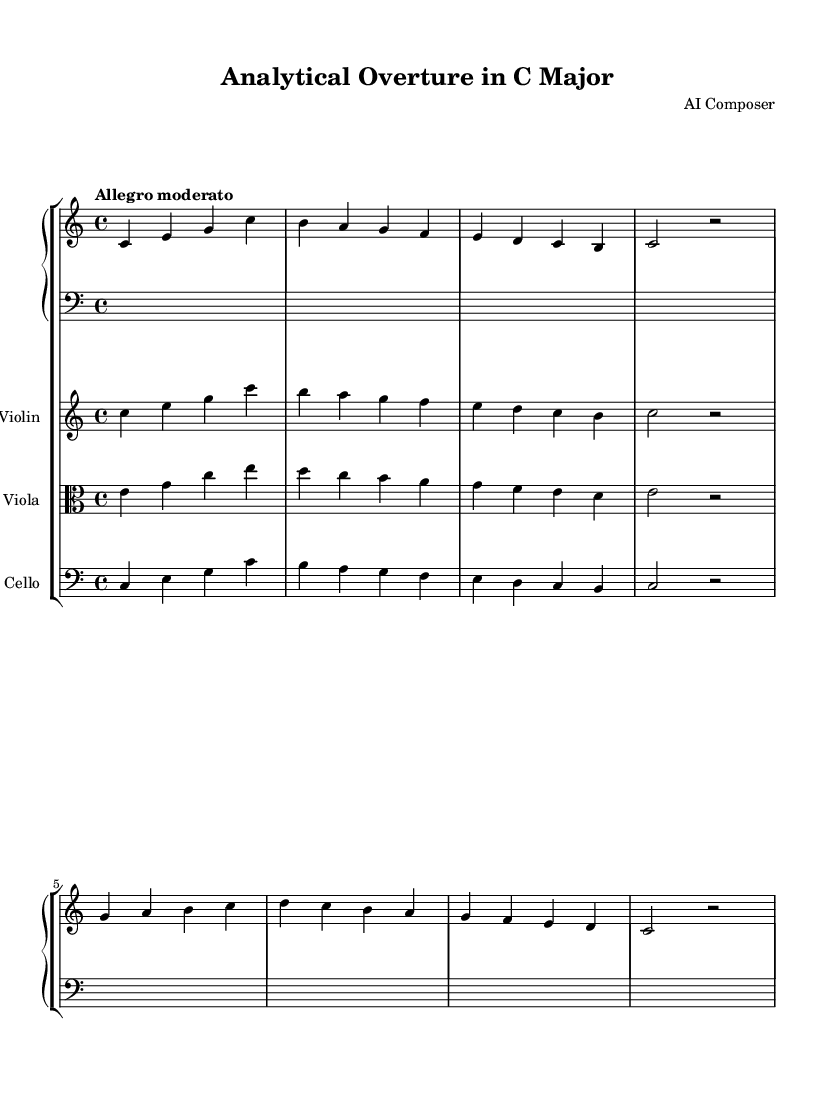What is the key signature of this music? The key signature is C major, which has no sharps or flats, as indicated by the absence of any accidentals at the beginning of the staff.
Answer: C major What is the time signature of this music? The time signature is 4/4, denoted by the notation found at the beginning of the score, meaning there are four beats per measure, and the quarter note gets one beat.
Answer: 4/4 What is the tempo marking of this piece? The tempo marking is "Allegro moderato," which suggests a moderately fast pace and can be found at the beginning above the staff.
Answer: Allegro moderato Which instrument plays the lowest notes? The cello plays the lowest notes, as it is written in the bass clef and its pitches are lower than those of the violin and viola.
Answer: Cello How many measures are in the piano part? The piano part has a total of eight measures, counted by the distinct groups of notes separated by vertical lines in the notation.
Answer: Eight What is the melodic range of the violin part? The violin part has a melodic range that spans from C to C', which starts from the lower C note and goes up to the higher C note an octave above.
Answer: C to C' Which instruments are included in this score? The score includes piano, violin, viola, and cello, as indicated by the labeled staves for each instrument at the beginning of the score.
Answer: Piano, Violin, Viola, Cello 